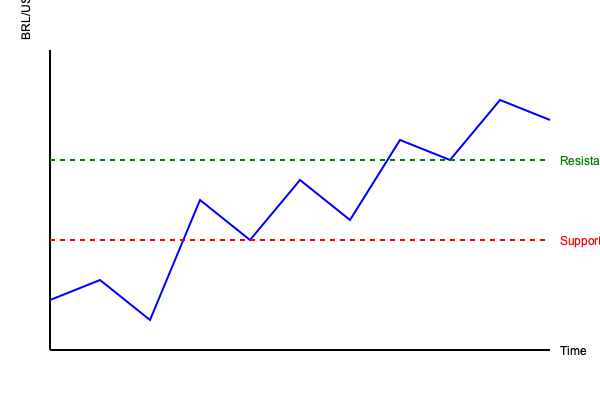Analyze the given line graph representing the historical performance of the Brazilian real (BRL) against the US dollar (USD). Identify the key support and resistance levels, and explain how these levels could influence your trading strategy for the BRL/USD pair in the near future. To identify support and resistance levels and develop a trading strategy based on the given graph, follow these steps:

1. Identify the support level:
   The red dashed line at approximately the 3.8 BRL/USD level represents a key support level. This is evident from multiple points where the price bounces off or stays above this level.

2. Identify the resistance level:
   The green dashed line at approximately the 3.2 BRL/USD level represents a key resistance level. The price tends to struggle to break above this level and often retreats when it approaches it.

3. Analyze the current trend:
   The overall trend appears to be bullish (strengthening BRL) as the price is making higher lows and higher highs over time.

4. Develop a trading strategy:
   a) Buy (go long) when the price approaches the support level (3.8 BRL/USD) and shows signs of bouncing off it.
   b) Sell (go short) or take profits when the price approaches the resistance level (3.2 BRL/USD).
   c) Place stop-loss orders slightly below the support level for long positions and slightly above the resistance level for short positions.
   d) Watch for potential breakouts: If the price breaks above the resistance level, it may signal a stronger BRL and a new uptrend. Conversely, if it breaks below the support level, it may indicate a weaker BRL and a potential downtrend.

5. Consider fundamental factors:
   While technical analysis is important, also consider fundamental factors affecting the Brazilian economy and global market conditions that may impact the BRL/USD pair.

6. Risk management:
   Always use proper position sizing and risk management techniques to protect your trading capital, especially when trading emerging market currencies like the Brazilian real.

By incorporating these support and resistance levels into your trading strategy, you can make more informed decisions about entry and exit points, as well as manage your risk effectively when trading the BRL/USD pair.
Answer: Buy near support (3.8 BRL/USD), sell near resistance (3.2 BRL/USD), watch for breakouts, and consider fundamental factors while maintaining proper risk management. 